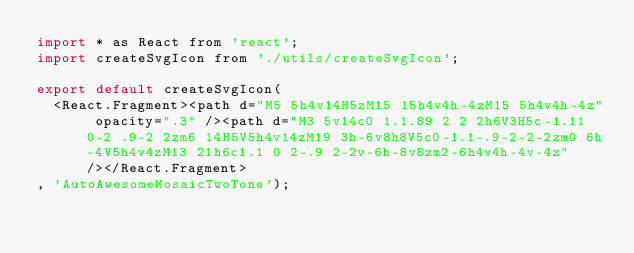<code> <loc_0><loc_0><loc_500><loc_500><_JavaScript_>import * as React from 'react';
import createSvgIcon from './utils/createSvgIcon';

export default createSvgIcon(
  <React.Fragment><path d="M5 5h4v14H5zM15 15h4v4h-4zM15 5h4v4h-4z" opacity=".3" /><path d="M3 5v14c0 1.1.89 2 2 2h6V3H5c-1.11 0-2 .9-2 2zm6 14H5V5h4v14zM19 3h-6v8h8V5c0-1.1-.9-2-2-2zm0 6h-4V5h4v4zM13 21h6c1.1 0 2-.9 2-2v-6h-8v8zm2-6h4v4h-4v-4z" /></React.Fragment>
, 'AutoAwesomeMosaicTwoTone');
</code> 